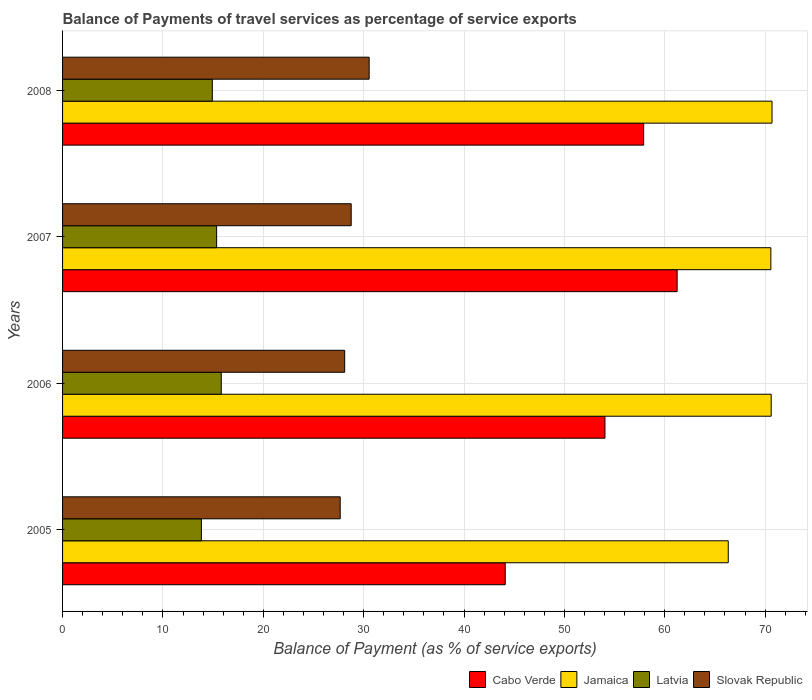How many groups of bars are there?
Provide a succinct answer. 4. Are the number of bars per tick equal to the number of legend labels?
Provide a succinct answer. Yes. How many bars are there on the 3rd tick from the top?
Ensure brevity in your answer.  4. What is the balance of payments of travel services in Cabo Verde in 2008?
Your response must be concise. 57.9. Across all years, what is the maximum balance of payments of travel services in Latvia?
Your answer should be compact. 15.81. Across all years, what is the minimum balance of payments of travel services in Slovak Republic?
Your answer should be compact. 27.66. In which year was the balance of payments of travel services in Latvia maximum?
Provide a short and direct response. 2006. In which year was the balance of payments of travel services in Latvia minimum?
Make the answer very short. 2005. What is the total balance of payments of travel services in Jamaica in the graph?
Offer a terse response. 278.19. What is the difference between the balance of payments of travel services in Jamaica in 2007 and that in 2008?
Ensure brevity in your answer.  -0.12. What is the difference between the balance of payments of travel services in Cabo Verde in 2006 and the balance of payments of travel services in Latvia in 2008?
Offer a terse response. 39.12. What is the average balance of payments of travel services in Cabo Verde per year?
Provide a short and direct response. 54.32. In the year 2008, what is the difference between the balance of payments of travel services in Slovak Republic and balance of payments of travel services in Latvia?
Provide a succinct answer. 15.63. In how many years, is the balance of payments of travel services in Latvia greater than 10 %?
Offer a terse response. 4. What is the ratio of the balance of payments of travel services in Slovak Republic in 2005 to that in 2007?
Your answer should be compact. 0.96. What is the difference between the highest and the second highest balance of payments of travel services in Latvia?
Keep it short and to the point. 0.46. What is the difference between the highest and the lowest balance of payments of travel services in Jamaica?
Your response must be concise. 4.36. In how many years, is the balance of payments of travel services in Jamaica greater than the average balance of payments of travel services in Jamaica taken over all years?
Offer a terse response. 3. What does the 3rd bar from the top in 2005 represents?
Offer a very short reply. Jamaica. What does the 2nd bar from the bottom in 2007 represents?
Make the answer very short. Jamaica. Is it the case that in every year, the sum of the balance of payments of travel services in Cabo Verde and balance of payments of travel services in Jamaica is greater than the balance of payments of travel services in Latvia?
Make the answer very short. Yes. Does the graph contain any zero values?
Provide a short and direct response. No. Does the graph contain grids?
Provide a succinct answer. Yes. How many legend labels are there?
Provide a short and direct response. 4. What is the title of the graph?
Keep it short and to the point. Balance of Payments of travel services as percentage of service exports. Does "Bhutan" appear as one of the legend labels in the graph?
Your answer should be compact. No. What is the label or title of the X-axis?
Offer a terse response. Balance of Payment (as % of service exports). What is the Balance of Payment (as % of service exports) of Cabo Verde in 2005?
Your response must be concise. 44.1. What is the Balance of Payment (as % of service exports) of Jamaica in 2005?
Ensure brevity in your answer.  66.32. What is the Balance of Payment (as % of service exports) in Latvia in 2005?
Keep it short and to the point. 13.83. What is the Balance of Payment (as % of service exports) of Slovak Republic in 2005?
Offer a very short reply. 27.66. What is the Balance of Payment (as % of service exports) in Cabo Verde in 2006?
Make the answer very short. 54.04. What is the Balance of Payment (as % of service exports) in Jamaica in 2006?
Offer a very short reply. 70.6. What is the Balance of Payment (as % of service exports) of Latvia in 2006?
Your response must be concise. 15.81. What is the Balance of Payment (as % of service exports) in Slovak Republic in 2006?
Keep it short and to the point. 28.11. What is the Balance of Payment (as % of service exports) in Cabo Verde in 2007?
Provide a succinct answer. 61.23. What is the Balance of Payment (as % of service exports) of Jamaica in 2007?
Keep it short and to the point. 70.57. What is the Balance of Payment (as % of service exports) in Latvia in 2007?
Provide a succinct answer. 15.35. What is the Balance of Payment (as % of service exports) of Slovak Republic in 2007?
Your answer should be compact. 28.76. What is the Balance of Payment (as % of service exports) of Cabo Verde in 2008?
Provide a succinct answer. 57.9. What is the Balance of Payment (as % of service exports) of Jamaica in 2008?
Your response must be concise. 70.69. What is the Balance of Payment (as % of service exports) in Latvia in 2008?
Your answer should be compact. 14.92. What is the Balance of Payment (as % of service exports) in Slovak Republic in 2008?
Your answer should be compact. 30.55. Across all years, what is the maximum Balance of Payment (as % of service exports) of Cabo Verde?
Keep it short and to the point. 61.23. Across all years, what is the maximum Balance of Payment (as % of service exports) in Jamaica?
Provide a short and direct response. 70.69. Across all years, what is the maximum Balance of Payment (as % of service exports) of Latvia?
Offer a terse response. 15.81. Across all years, what is the maximum Balance of Payment (as % of service exports) of Slovak Republic?
Provide a short and direct response. 30.55. Across all years, what is the minimum Balance of Payment (as % of service exports) in Cabo Verde?
Offer a very short reply. 44.1. Across all years, what is the minimum Balance of Payment (as % of service exports) of Jamaica?
Provide a short and direct response. 66.32. Across all years, what is the minimum Balance of Payment (as % of service exports) in Latvia?
Offer a very short reply. 13.83. Across all years, what is the minimum Balance of Payment (as % of service exports) in Slovak Republic?
Your response must be concise. 27.66. What is the total Balance of Payment (as % of service exports) of Cabo Verde in the graph?
Make the answer very short. 217.28. What is the total Balance of Payment (as % of service exports) of Jamaica in the graph?
Give a very brief answer. 278.19. What is the total Balance of Payment (as % of service exports) of Latvia in the graph?
Keep it short and to the point. 59.91. What is the total Balance of Payment (as % of service exports) in Slovak Republic in the graph?
Give a very brief answer. 115.08. What is the difference between the Balance of Payment (as % of service exports) of Cabo Verde in 2005 and that in 2006?
Your answer should be compact. -9.94. What is the difference between the Balance of Payment (as % of service exports) of Jamaica in 2005 and that in 2006?
Provide a succinct answer. -4.28. What is the difference between the Balance of Payment (as % of service exports) of Latvia in 2005 and that in 2006?
Your answer should be very brief. -1.98. What is the difference between the Balance of Payment (as % of service exports) of Slovak Republic in 2005 and that in 2006?
Offer a terse response. -0.45. What is the difference between the Balance of Payment (as % of service exports) in Cabo Verde in 2005 and that in 2007?
Offer a very short reply. -17.13. What is the difference between the Balance of Payment (as % of service exports) in Jamaica in 2005 and that in 2007?
Offer a very short reply. -4.25. What is the difference between the Balance of Payment (as % of service exports) of Latvia in 2005 and that in 2007?
Provide a short and direct response. -1.52. What is the difference between the Balance of Payment (as % of service exports) of Slovak Republic in 2005 and that in 2007?
Your response must be concise. -1.1. What is the difference between the Balance of Payment (as % of service exports) in Cabo Verde in 2005 and that in 2008?
Ensure brevity in your answer.  -13.79. What is the difference between the Balance of Payment (as % of service exports) in Jamaica in 2005 and that in 2008?
Make the answer very short. -4.36. What is the difference between the Balance of Payment (as % of service exports) of Latvia in 2005 and that in 2008?
Ensure brevity in your answer.  -1.09. What is the difference between the Balance of Payment (as % of service exports) in Slovak Republic in 2005 and that in 2008?
Offer a terse response. -2.89. What is the difference between the Balance of Payment (as % of service exports) of Cabo Verde in 2006 and that in 2007?
Give a very brief answer. -7.19. What is the difference between the Balance of Payment (as % of service exports) in Jamaica in 2006 and that in 2007?
Your answer should be very brief. 0.03. What is the difference between the Balance of Payment (as % of service exports) of Latvia in 2006 and that in 2007?
Provide a short and direct response. 0.46. What is the difference between the Balance of Payment (as % of service exports) in Slovak Republic in 2006 and that in 2007?
Make the answer very short. -0.65. What is the difference between the Balance of Payment (as % of service exports) in Cabo Verde in 2006 and that in 2008?
Keep it short and to the point. -3.86. What is the difference between the Balance of Payment (as % of service exports) in Jamaica in 2006 and that in 2008?
Your answer should be compact. -0.08. What is the difference between the Balance of Payment (as % of service exports) in Latvia in 2006 and that in 2008?
Offer a terse response. 0.89. What is the difference between the Balance of Payment (as % of service exports) in Slovak Republic in 2006 and that in 2008?
Your response must be concise. -2.44. What is the difference between the Balance of Payment (as % of service exports) in Cabo Verde in 2007 and that in 2008?
Your answer should be very brief. 3.33. What is the difference between the Balance of Payment (as % of service exports) of Jamaica in 2007 and that in 2008?
Offer a terse response. -0.12. What is the difference between the Balance of Payment (as % of service exports) of Latvia in 2007 and that in 2008?
Provide a succinct answer. 0.43. What is the difference between the Balance of Payment (as % of service exports) of Slovak Republic in 2007 and that in 2008?
Your answer should be compact. -1.79. What is the difference between the Balance of Payment (as % of service exports) in Cabo Verde in 2005 and the Balance of Payment (as % of service exports) in Jamaica in 2006?
Make the answer very short. -26.5. What is the difference between the Balance of Payment (as % of service exports) of Cabo Verde in 2005 and the Balance of Payment (as % of service exports) of Latvia in 2006?
Your answer should be very brief. 28.29. What is the difference between the Balance of Payment (as % of service exports) in Cabo Verde in 2005 and the Balance of Payment (as % of service exports) in Slovak Republic in 2006?
Offer a very short reply. 15.99. What is the difference between the Balance of Payment (as % of service exports) of Jamaica in 2005 and the Balance of Payment (as % of service exports) of Latvia in 2006?
Ensure brevity in your answer.  50.51. What is the difference between the Balance of Payment (as % of service exports) in Jamaica in 2005 and the Balance of Payment (as % of service exports) in Slovak Republic in 2006?
Give a very brief answer. 38.22. What is the difference between the Balance of Payment (as % of service exports) in Latvia in 2005 and the Balance of Payment (as % of service exports) in Slovak Republic in 2006?
Your answer should be very brief. -14.28. What is the difference between the Balance of Payment (as % of service exports) in Cabo Verde in 2005 and the Balance of Payment (as % of service exports) in Jamaica in 2007?
Your response must be concise. -26.47. What is the difference between the Balance of Payment (as % of service exports) in Cabo Verde in 2005 and the Balance of Payment (as % of service exports) in Latvia in 2007?
Ensure brevity in your answer.  28.75. What is the difference between the Balance of Payment (as % of service exports) of Cabo Verde in 2005 and the Balance of Payment (as % of service exports) of Slovak Republic in 2007?
Make the answer very short. 15.35. What is the difference between the Balance of Payment (as % of service exports) of Jamaica in 2005 and the Balance of Payment (as % of service exports) of Latvia in 2007?
Provide a succinct answer. 50.97. What is the difference between the Balance of Payment (as % of service exports) in Jamaica in 2005 and the Balance of Payment (as % of service exports) in Slovak Republic in 2007?
Give a very brief answer. 37.57. What is the difference between the Balance of Payment (as % of service exports) of Latvia in 2005 and the Balance of Payment (as % of service exports) of Slovak Republic in 2007?
Your answer should be compact. -14.93. What is the difference between the Balance of Payment (as % of service exports) of Cabo Verde in 2005 and the Balance of Payment (as % of service exports) of Jamaica in 2008?
Provide a short and direct response. -26.58. What is the difference between the Balance of Payment (as % of service exports) of Cabo Verde in 2005 and the Balance of Payment (as % of service exports) of Latvia in 2008?
Your answer should be compact. 29.18. What is the difference between the Balance of Payment (as % of service exports) in Cabo Verde in 2005 and the Balance of Payment (as % of service exports) in Slovak Republic in 2008?
Ensure brevity in your answer.  13.55. What is the difference between the Balance of Payment (as % of service exports) of Jamaica in 2005 and the Balance of Payment (as % of service exports) of Latvia in 2008?
Your response must be concise. 51.4. What is the difference between the Balance of Payment (as % of service exports) of Jamaica in 2005 and the Balance of Payment (as % of service exports) of Slovak Republic in 2008?
Your answer should be very brief. 35.78. What is the difference between the Balance of Payment (as % of service exports) in Latvia in 2005 and the Balance of Payment (as % of service exports) in Slovak Republic in 2008?
Your answer should be very brief. -16.72. What is the difference between the Balance of Payment (as % of service exports) in Cabo Verde in 2006 and the Balance of Payment (as % of service exports) in Jamaica in 2007?
Make the answer very short. -16.53. What is the difference between the Balance of Payment (as % of service exports) in Cabo Verde in 2006 and the Balance of Payment (as % of service exports) in Latvia in 2007?
Your response must be concise. 38.69. What is the difference between the Balance of Payment (as % of service exports) of Cabo Verde in 2006 and the Balance of Payment (as % of service exports) of Slovak Republic in 2007?
Your response must be concise. 25.28. What is the difference between the Balance of Payment (as % of service exports) in Jamaica in 2006 and the Balance of Payment (as % of service exports) in Latvia in 2007?
Ensure brevity in your answer.  55.25. What is the difference between the Balance of Payment (as % of service exports) of Jamaica in 2006 and the Balance of Payment (as % of service exports) of Slovak Republic in 2007?
Your answer should be very brief. 41.85. What is the difference between the Balance of Payment (as % of service exports) in Latvia in 2006 and the Balance of Payment (as % of service exports) in Slovak Republic in 2007?
Provide a short and direct response. -12.95. What is the difference between the Balance of Payment (as % of service exports) in Cabo Verde in 2006 and the Balance of Payment (as % of service exports) in Jamaica in 2008?
Provide a succinct answer. -16.64. What is the difference between the Balance of Payment (as % of service exports) in Cabo Verde in 2006 and the Balance of Payment (as % of service exports) in Latvia in 2008?
Offer a terse response. 39.12. What is the difference between the Balance of Payment (as % of service exports) in Cabo Verde in 2006 and the Balance of Payment (as % of service exports) in Slovak Republic in 2008?
Give a very brief answer. 23.49. What is the difference between the Balance of Payment (as % of service exports) of Jamaica in 2006 and the Balance of Payment (as % of service exports) of Latvia in 2008?
Make the answer very short. 55.68. What is the difference between the Balance of Payment (as % of service exports) of Jamaica in 2006 and the Balance of Payment (as % of service exports) of Slovak Republic in 2008?
Provide a short and direct response. 40.05. What is the difference between the Balance of Payment (as % of service exports) in Latvia in 2006 and the Balance of Payment (as % of service exports) in Slovak Republic in 2008?
Offer a terse response. -14.74. What is the difference between the Balance of Payment (as % of service exports) in Cabo Verde in 2007 and the Balance of Payment (as % of service exports) in Jamaica in 2008?
Keep it short and to the point. -9.45. What is the difference between the Balance of Payment (as % of service exports) of Cabo Verde in 2007 and the Balance of Payment (as % of service exports) of Latvia in 2008?
Your answer should be very brief. 46.31. What is the difference between the Balance of Payment (as % of service exports) of Cabo Verde in 2007 and the Balance of Payment (as % of service exports) of Slovak Republic in 2008?
Your answer should be very brief. 30.68. What is the difference between the Balance of Payment (as % of service exports) in Jamaica in 2007 and the Balance of Payment (as % of service exports) in Latvia in 2008?
Your answer should be compact. 55.65. What is the difference between the Balance of Payment (as % of service exports) of Jamaica in 2007 and the Balance of Payment (as % of service exports) of Slovak Republic in 2008?
Ensure brevity in your answer.  40.02. What is the difference between the Balance of Payment (as % of service exports) of Latvia in 2007 and the Balance of Payment (as % of service exports) of Slovak Republic in 2008?
Your response must be concise. -15.2. What is the average Balance of Payment (as % of service exports) in Cabo Verde per year?
Provide a short and direct response. 54.32. What is the average Balance of Payment (as % of service exports) of Jamaica per year?
Make the answer very short. 69.55. What is the average Balance of Payment (as % of service exports) of Latvia per year?
Offer a very short reply. 14.98. What is the average Balance of Payment (as % of service exports) of Slovak Republic per year?
Ensure brevity in your answer.  28.77. In the year 2005, what is the difference between the Balance of Payment (as % of service exports) in Cabo Verde and Balance of Payment (as % of service exports) in Jamaica?
Keep it short and to the point. -22.22. In the year 2005, what is the difference between the Balance of Payment (as % of service exports) of Cabo Verde and Balance of Payment (as % of service exports) of Latvia?
Keep it short and to the point. 30.27. In the year 2005, what is the difference between the Balance of Payment (as % of service exports) of Cabo Verde and Balance of Payment (as % of service exports) of Slovak Republic?
Your answer should be very brief. 16.44. In the year 2005, what is the difference between the Balance of Payment (as % of service exports) of Jamaica and Balance of Payment (as % of service exports) of Latvia?
Give a very brief answer. 52.49. In the year 2005, what is the difference between the Balance of Payment (as % of service exports) in Jamaica and Balance of Payment (as % of service exports) in Slovak Republic?
Give a very brief answer. 38.66. In the year 2005, what is the difference between the Balance of Payment (as % of service exports) of Latvia and Balance of Payment (as % of service exports) of Slovak Republic?
Ensure brevity in your answer.  -13.83. In the year 2006, what is the difference between the Balance of Payment (as % of service exports) in Cabo Verde and Balance of Payment (as % of service exports) in Jamaica?
Provide a succinct answer. -16.56. In the year 2006, what is the difference between the Balance of Payment (as % of service exports) in Cabo Verde and Balance of Payment (as % of service exports) in Latvia?
Offer a terse response. 38.23. In the year 2006, what is the difference between the Balance of Payment (as % of service exports) in Cabo Verde and Balance of Payment (as % of service exports) in Slovak Republic?
Make the answer very short. 25.93. In the year 2006, what is the difference between the Balance of Payment (as % of service exports) of Jamaica and Balance of Payment (as % of service exports) of Latvia?
Your response must be concise. 54.79. In the year 2006, what is the difference between the Balance of Payment (as % of service exports) of Jamaica and Balance of Payment (as % of service exports) of Slovak Republic?
Offer a very short reply. 42.49. In the year 2006, what is the difference between the Balance of Payment (as % of service exports) of Latvia and Balance of Payment (as % of service exports) of Slovak Republic?
Your answer should be very brief. -12.3. In the year 2007, what is the difference between the Balance of Payment (as % of service exports) in Cabo Verde and Balance of Payment (as % of service exports) in Jamaica?
Provide a short and direct response. -9.34. In the year 2007, what is the difference between the Balance of Payment (as % of service exports) in Cabo Verde and Balance of Payment (as % of service exports) in Latvia?
Ensure brevity in your answer.  45.88. In the year 2007, what is the difference between the Balance of Payment (as % of service exports) of Cabo Verde and Balance of Payment (as % of service exports) of Slovak Republic?
Provide a succinct answer. 32.48. In the year 2007, what is the difference between the Balance of Payment (as % of service exports) of Jamaica and Balance of Payment (as % of service exports) of Latvia?
Your response must be concise. 55.22. In the year 2007, what is the difference between the Balance of Payment (as % of service exports) of Jamaica and Balance of Payment (as % of service exports) of Slovak Republic?
Give a very brief answer. 41.81. In the year 2007, what is the difference between the Balance of Payment (as % of service exports) of Latvia and Balance of Payment (as % of service exports) of Slovak Republic?
Keep it short and to the point. -13.41. In the year 2008, what is the difference between the Balance of Payment (as % of service exports) of Cabo Verde and Balance of Payment (as % of service exports) of Jamaica?
Provide a succinct answer. -12.79. In the year 2008, what is the difference between the Balance of Payment (as % of service exports) of Cabo Verde and Balance of Payment (as % of service exports) of Latvia?
Provide a succinct answer. 42.98. In the year 2008, what is the difference between the Balance of Payment (as % of service exports) of Cabo Verde and Balance of Payment (as % of service exports) of Slovak Republic?
Ensure brevity in your answer.  27.35. In the year 2008, what is the difference between the Balance of Payment (as % of service exports) of Jamaica and Balance of Payment (as % of service exports) of Latvia?
Provide a short and direct response. 55.77. In the year 2008, what is the difference between the Balance of Payment (as % of service exports) of Jamaica and Balance of Payment (as % of service exports) of Slovak Republic?
Keep it short and to the point. 40.14. In the year 2008, what is the difference between the Balance of Payment (as % of service exports) of Latvia and Balance of Payment (as % of service exports) of Slovak Republic?
Offer a very short reply. -15.63. What is the ratio of the Balance of Payment (as % of service exports) in Cabo Verde in 2005 to that in 2006?
Provide a succinct answer. 0.82. What is the ratio of the Balance of Payment (as % of service exports) of Jamaica in 2005 to that in 2006?
Offer a terse response. 0.94. What is the ratio of the Balance of Payment (as % of service exports) in Latvia in 2005 to that in 2006?
Give a very brief answer. 0.87. What is the ratio of the Balance of Payment (as % of service exports) in Slovak Republic in 2005 to that in 2006?
Your answer should be compact. 0.98. What is the ratio of the Balance of Payment (as % of service exports) in Cabo Verde in 2005 to that in 2007?
Provide a short and direct response. 0.72. What is the ratio of the Balance of Payment (as % of service exports) of Jamaica in 2005 to that in 2007?
Provide a short and direct response. 0.94. What is the ratio of the Balance of Payment (as % of service exports) in Latvia in 2005 to that in 2007?
Provide a short and direct response. 0.9. What is the ratio of the Balance of Payment (as % of service exports) of Slovak Republic in 2005 to that in 2007?
Provide a succinct answer. 0.96. What is the ratio of the Balance of Payment (as % of service exports) in Cabo Verde in 2005 to that in 2008?
Ensure brevity in your answer.  0.76. What is the ratio of the Balance of Payment (as % of service exports) in Jamaica in 2005 to that in 2008?
Make the answer very short. 0.94. What is the ratio of the Balance of Payment (as % of service exports) in Latvia in 2005 to that in 2008?
Offer a very short reply. 0.93. What is the ratio of the Balance of Payment (as % of service exports) in Slovak Republic in 2005 to that in 2008?
Keep it short and to the point. 0.91. What is the ratio of the Balance of Payment (as % of service exports) in Cabo Verde in 2006 to that in 2007?
Offer a very short reply. 0.88. What is the ratio of the Balance of Payment (as % of service exports) in Jamaica in 2006 to that in 2007?
Make the answer very short. 1. What is the ratio of the Balance of Payment (as % of service exports) in Slovak Republic in 2006 to that in 2007?
Your answer should be compact. 0.98. What is the ratio of the Balance of Payment (as % of service exports) in Cabo Verde in 2006 to that in 2008?
Give a very brief answer. 0.93. What is the ratio of the Balance of Payment (as % of service exports) in Jamaica in 2006 to that in 2008?
Ensure brevity in your answer.  1. What is the ratio of the Balance of Payment (as % of service exports) in Latvia in 2006 to that in 2008?
Your answer should be very brief. 1.06. What is the ratio of the Balance of Payment (as % of service exports) of Slovak Republic in 2006 to that in 2008?
Keep it short and to the point. 0.92. What is the ratio of the Balance of Payment (as % of service exports) in Cabo Verde in 2007 to that in 2008?
Your response must be concise. 1.06. What is the ratio of the Balance of Payment (as % of service exports) in Latvia in 2007 to that in 2008?
Give a very brief answer. 1.03. What is the ratio of the Balance of Payment (as % of service exports) of Slovak Republic in 2007 to that in 2008?
Your response must be concise. 0.94. What is the difference between the highest and the second highest Balance of Payment (as % of service exports) in Cabo Verde?
Provide a succinct answer. 3.33. What is the difference between the highest and the second highest Balance of Payment (as % of service exports) in Jamaica?
Your answer should be very brief. 0.08. What is the difference between the highest and the second highest Balance of Payment (as % of service exports) in Latvia?
Your answer should be compact. 0.46. What is the difference between the highest and the second highest Balance of Payment (as % of service exports) in Slovak Republic?
Your answer should be compact. 1.79. What is the difference between the highest and the lowest Balance of Payment (as % of service exports) of Cabo Verde?
Keep it short and to the point. 17.13. What is the difference between the highest and the lowest Balance of Payment (as % of service exports) of Jamaica?
Your answer should be compact. 4.36. What is the difference between the highest and the lowest Balance of Payment (as % of service exports) in Latvia?
Keep it short and to the point. 1.98. What is the difference between the highest and the lowest Balance of Payment (as % of service exports) of Slovak Republic?
Provide a short and direct response. 2.89. 